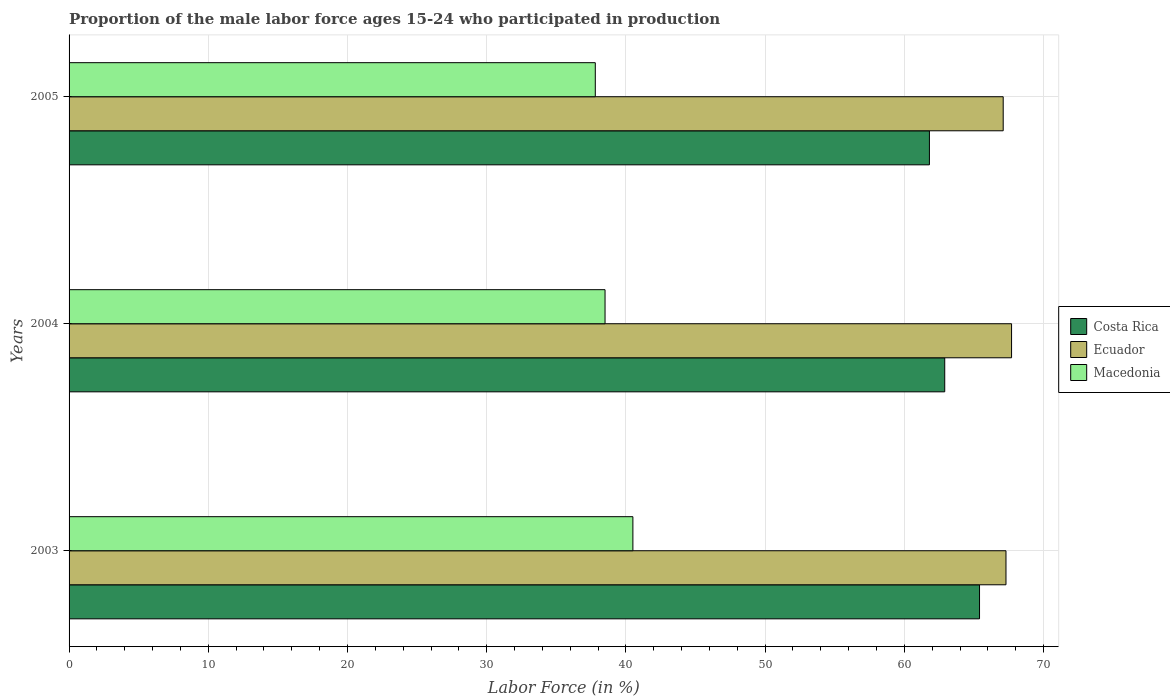How many different coloured bars are there?
Keep it short and to the point. 3. Are the number of bars per tick equal to the number of legend labels?
Give a very brief answer. Yes. Are the number of bars on each tick of the Y-axis equal?
Provide a short and direct response. Yes. How many bars are there on the 1st tick from the top?
Your answer should be compact. 3. How many bars are there on the 2nd tick from the bottom?
Give a very brief answer. 3. What is the proportion of the male labor force who participated in production in Macedonia in 2004?
Offer a terse response. 38.5. Across all years, what is the maximum proportion of the male labor force who participated in production in Ecuador?
Provide a short and direct response. 67.7. Across all years, what is the minimum proportion of the male labor force who participated in production in Costa Rica?
Your answer should be very brief. 61.8. In which year was the proportion of the male labor force who participated in production in Costa Rica maximum?
Offer a very short reply. 2003. In which year was the proportion of the male labor force who participated in production in Ecuador minimum?
Your response must be concise. 2005. What is the total proportion of the male labor force who participated in production in Ecuador in the graph?
Ensure brevity in your answer.  202.1. What is the difference between the proportion of the male labor force who participated in production in Costa Rica in 2005 and the proportion of the male labor force who participated in production in Ecuador in 2003?
Your answer should be compact. -5.5. What is the average proportion of the male labor force who participated in production in Macedonia per year?
Keep it short and to the point. 38.93. In the year 2005, what is the difference between the proportion of the male labor force who participated in production in Macedonia and proportion of the male labor force who participated in production in Costa Rica?
Ensure brevity in your answer.  -24. What is the ratio of the proportion of the male labor force who participated in production in Ecuador in 2004 to that in 2005?
Ensure brevity in your answer.  1.01. Is the proportion of the male labor force who participated in production in Macedonia in 2004 less than that in 2005?
Keep it short and to the point. No. What is the difference between the highest and the second highest proportion of the male labor force who participated in production in Ecuador?
Give a very brief answer. 0.4. What is the difference between the highest and the lowest proportion of the male labor force who participated in production in Costa Rica?
Offer a terse response. 3.6. What does the 3rd bar from the top in 2004 represents?
Offer a terse response. Costa Rica. What does the 1st bar from the bottom in 2003 represents?
Ensure brevity in your answer.  Costa Rica. Is it the case that in every year, the sum of the proportion of the male labor force who participated in production in Costa Rica and proportion of the male labor force who participated in production in Ecuador is greater than the proportion of the male labor force who participated in production in Macedonia?
Make the answer very short. Yes. Are all the bars in the graph horizontal?
Give a very brief answer. Yes. Are the values on the major ticks of X-axis written in scientific E-notation?
Offer a terse response. No. Where does the legend appear in the graph?
Your answer should be very brief. Center right. How are the legend labels stacked?
Offer a very short reply. Vertical. What is the title of the graph?
Offer a very short reply. Proportion of the male labor force ages 15-24 who participated in production. What is the label or title of the X-axis?
Give a very brief answer. Labor Force (in %). What is the label or title of the Y-axis?
Keep it short and to the point. Years. What is the Labor Force (in %) in Costa Rica in 2003?
Give a very brief answer. 65.4. What is the Labor Force (in %) in Ecuador in 2003?
Your answer should be very brief. 67.3. What is the Labor Force (in %) of Macedonia in 2003?
Make the answer very short. 40.5. What is the Labor Force (in %) of Costa Rica in 2004?
Provide a short and direct response. 62.9. What is the Labor Force (in %) of Ecuador in 2004?
Your answer should be very brief. 67.7. What is the Labor Force (in %) of Macedonia in 2004?
Ensure brevity in your answer.  38.5. What is the Labor Force (in %) of Costa Rica in 2005?
Provide a short and direct response. 61.8. What is the Labor Force (in %) of Ecuador in 2005?
Offer a very short reply. 67.1. What is the Labor Force (in %) of Macedonia in 2005?
Offer a terse response. 37.8. Across all years, what is the maximum Labor Force (in %) of Costa Rica?
Your response must be concise. 65.4. Across all years, what is the maximum Labor Force (in %) in Ecuador?
Provide a short and direct response. 67.7. Across all years, what is the maximum Labor Force (in %) of Macedonia?
Your response must be concise. 40.5. Across all years, what is the minimum Labor Force (in %) of Costa Rica?
Your answer should be very brief. 61.8. Across all years, what is the minimum Labor Force (in %) in Ecuador?
Offer a very short reply. 67.1. Across all years, what is the minimum Labor Force (in %) in Macedonia?
Provide a succinct answer. 37.8. What is the total Labor Force (in %) in Costa Rica in the graph?
Offer a terse response. 190.1. What is the total Labor Force (in %) in Ecuador in the graph?
Offer a terse response. 202.1. What is the total Labor Force (in %) in Macedonia in the graph?
Your answer should be very brief. 116.8. What is the difference between the Labor Force (in %) in Macedonia in 2003 and that in 2004?
Your response must be concise. 2. What is the difference between the Labor Force (in %) in Costa Rica in 2003 and that in 2005?
Offer a terse response. 3.6. What is the difference between the Labor Force (in %) in Ecuador in 2003 and that in 2005?
Your answer should be very brief. 0.2. What is the difference between the Labor Force (in %) in Ecuador in 2004 and that in 2005?
Give a very brief answer. 0.6. What is the difference between the Labor Force (in %) in Macedonia in 2004 and that in 2005?
Your answer should be very brief. 0.7. What is the difference between the Labor Force (in %) in Costa Rica in 2003 and the Labor Force (in %) in Ecuador in 2004?
Make the answer very short. -2.3. What is the difference between the Labor Force (in %) of Costa Rica in 2003 and the Labor Force (in %) of Macedonia in 2004?
Ensure brevity in your answer.  26.9. What is the difference between the Labor Force (in %) in Ecuador in 2003 and the Labor Force (in %) in Macedonia in 2004?
Your answer should be compact. 28.8. What is the difference between the Labor Force (in %) in Costa Rica in 2003 and the Labor Force (in %) in Macedonia in 2005?
Provide a succinct answer. 27.6. What is the difference between the Labor Force (in %) in Ecuador in 2003 and the Labor Force (in %) in Macedonia in 2005?
Your answer should be very brief. 29.5. What is the difference between the Labor Force (in %) in Costa Rica in 2004 and the Labor Force (in %) in Ecuador in 2005?
Ensure brevity in your answer.  -4.2. What is the difference between the Labor Force (in %) of Costa Rica in 2004 and the Labor Force (in %) of Macedonia in 2005?
Keep it short and to the point. 25.1. What is the difference between the Labor Force (in %) of Ecuador in 2004 and the Labor Force (in %) of Macedonia in 2005?
Make the answer very short. 29.9. What is the average Labor Force (in %) of Costa Rica per year?
Give a very brief answer. 63.37. What is the average Labor Force (in %) of Ecuador per year?
Your answer should be compact. 67.37. What is the average Labor Force (in %) of Macedonia per year?
Keep it short and to the point. 38.93. In the year 2003, what is the difference between the Labor Force (in %) in Costa Rica and Labor Force (in %) in Macedonia?
Give a very brief answer. 24.9. In the year 2003, what is the difference between the Labor Force (in %) in Ecuador and Labor Force (in %) in Macedonia?
Offer a terse response. 26.8. In the year 2004, what is the difference between the Labor Force (in %) in Costa Rica and Labor Force (in %) in Macedonia?
Offer a terse response. 24.4. In the year 2004, what is the difference between the Labor Force (in %) of Ecuador and Labor Force (in %) of Macedonia?
Make the answer very short. 29.2. In the year 2005, what is the difference between the Labor Force (in %) of Costa Rica and Labor Force (in %) of Ecuador?
Your response must be concise. -5.3. In the year 2005, what is the difference between the Labor Force (in %) in Ecuador and Labor Force (in %) in Macedonia?
Provide a short and direct response. 29.3. What is the ratio of the Labor Force (in %) in Costa Rica in 2003 to that in 2004?
Your response must be concise. 1.04. What is the ratio of the Labor Force (in %) in Ecuador in 2003 to that in 2004?
Ensure brevity in your answer.  0.99. What is the ratio of the Labor Force (in %) in Macedonia in 2003 to that in 2004?
Offer a terse response. 1.05. What is the ratio of the Labor Force (in %) of Costa Rica in 2003 to that in 2005?
Your response must be concise. 1.06. What is the ratio of the Labor Force (in %) in Macedonia in 2003 to that in 2005?
Make the answer very short. 1.07. What is the ratio of the Labor Force (in %) in Costa Rica in 2004 to that in 2005?
Offer a terse response. 1.02. What is the ratio of the Labor Force (in %) of Ecuador in 2004 to that in 2005?
Ensure brevity in your answer.  1.01. What is the ratio of the Labor Force (in %) of Macedonia in 2004 to that in 2005?
Offer a terse response. 1.02. What is the difference between the highest and the second highest Labor Force (in %) in Costa Rica?
Offer a terse response. 2.5. What is the difference between the highest and the lowest Labor Force (in %) in Costa Rica?
Offer a terse response. 3.6. What is the difference between the highest and the lowest Labor Force (in %) of Ecuador?
Provide a short and direct response. 0.6. 